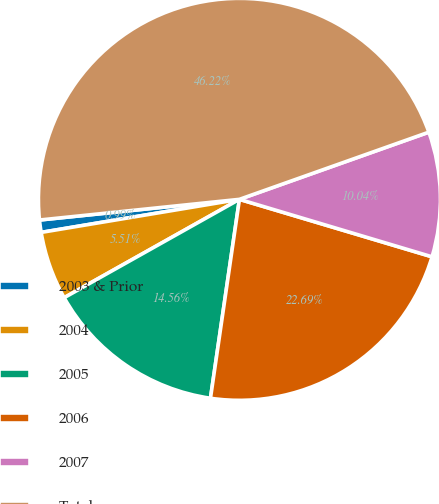Convert chart. <chart><loc_0><loc_0><loc_500><loc_500><pie_chart><fcel>2003 & Prior<fcel>2004<fcel>2005<fcel>2006<fcel>2007<fcel>Total<nl><fcel>0.99%<fcel>5.51%<fcel>14.56%<fcel>22.69%<fcel>10.04%<fcel>46.22%<nl></chart> 